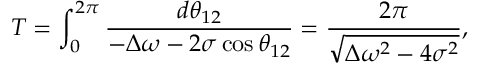Convert formula to latex. <formula><loc_0><loc_0><loc_500><loc_500>T = \int _ { 0 } ^ { 2 \pi } \frac { d \theta _ { 1 2 } } { - \Delta \omega - 2 \sigma \cos \theta _ { 1 2 } } = \frac { 2 \pi } { \sqrt { \Delta \omega ^ { 2 } - 4 \sigma ^ { 2 } } } ,</formula> 